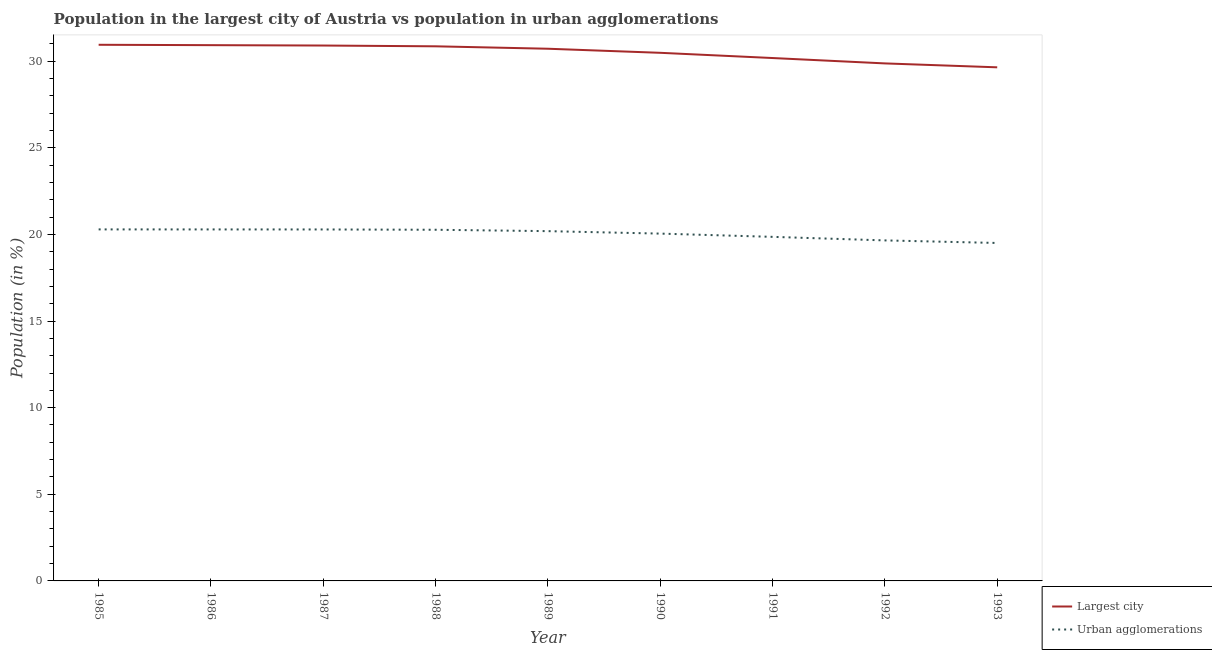How many different coloured lines are there?
Provide a succinct answer. 2. Does the line corresponding to population in the largest city intersect with the line corresponding to population in urban agglomerations?
Keep it short and to the point. No. Is the number of lines equal to the number of legend labels?
Offer a terse response. Yes. What is the population in urban agglomerations in 1989?
Keep it short and to the point. 20.19. Across all years, what is the maximum population in the largest city?
Your response must be concise. 30.94. Across all years, what is the minimum population in urban agglomerations?
Your answer should be very brief. 19.51. In which year was the population in the largest city maximum?
Ensure brevity in your answer.  1985. What is the total population in the largest city in the graph?
Offer a terse response. 274.51. What is the difference between the population in urban agglomerations in 1987 and that in 1993?
Give a very brief answer. 0.78. What is the difference between the population in the largest city in 1990 and the population in urban agglomerations in 1986?
Offer a very short reply. 10.19. What is the average population in urban agglomerations per year?
Your answer should be very brief. 20.04. In the year 1989, what is the difference between the population in the largest city and population in urban agglomerations?
Provide a short and direct response. 10.53. What is the ratio of the population in the largest city in 1988 to that in 1993?
Provide a succinct answer. 1.04. What is the difference between the highest and the second highest population in the largest city?
Offer a terse response. 0.02. What is the difference between the highest and the lowest population in urban agglomerations?
Offer a terse response. 0.78. Is the sum of the population in urban agglomerations in 1992 and 1993 greater than the maximum population in the largest city across all years?
Ensure brevity in your answer.  Yes. Is the population in urban agglomerations strictly greater than the population in the largest city over the years?
Your answer should be compact. No. How many lines are there?
Provide a succinct answer. 2. Are the values on the major ticks of Y-axis written in scientific E-notation?
Ensure brevity in your answer.  No. Does the graph contain grids?
Offer a very short reply. No. How are the legend labels stacked?
Keep it short and to the point. Vertical. What is the title of the graph?
Offer a very short reply. Population in the largest city of Austria vs population in urban agglomerations. Does "Primary income" appear as one of the legend labels in the graph?
Provide a succinct answer. No. What is the Population (in %) in Largest city in 1985?
Ensure brevity in your answer.  30.94. What is the Population (in %) of Urban agglomerations in 1985?
Provide a succinct answer. 20.29. What is the Population (in %) of Largest city in 1986?
Keep it short and to the point. 30.92. What is the Population (in %) in Urban agglomerations in 1986?
Offer a very short reply. 20.29. What is the Population (in %) of Largest city in 1987?
Your response must be concise. 30.9. What is the Population (in %) of Urban agglomerations in 1987?
Make the answer very short. 20.29. What is the Population (in %) of Largest city in 1988?
Your answer should be very brief. 30.86. What is the Population (in %) in Urban agglomerations in 1988?
Make the answer very short. 20.27. What is the Population (in %) of Largest city in 1989?
Provide a short and direct response. 30.72. What is the Population (in %) of Urban agglomerations in 1989?
Your response must be concise. 20.19. What is the Population (in %) in Largest city in 1990?
Provide a succinct answer. 30.48. What is the Population (in %) in Urban agglomerations in 1990?
Offer a very short reply. 20.05. What is the Population (in %) in Largest city in 1991?
Make the answer very short. 30.18. What is the Population (in %) of Urban agglomerations in 1991?
Offer a very short reply. 19.86. What is the Population (in %) of Largest city in 1992?
Provide a succinct answer. 29.87. What is the Population (in %) of Urban agglomerations in 1992?
Your answer should be compact. 19.65. What is the Population (in %) of Largest city in 1993?
Your answer should be compact. 29.64. What is the Population (in %) in Urban agglomerations in 1993?
Provide a succinct answer. 19.51. Across all years, what is the maximum Population (in %) in Largest city?
Make the answer very short. 30.94. Across all years, what is the maximum Population (in %) in Urban agglomerations?
Your response must be concise. 20.29. Across all years, what is the minimum Population (in %) of Largest city?
Your answer should be very brief. 29.64. Across all years, what is the minimum Population (in %) of Urban agglomerations?
Keep it short and to the point. 19.51. What is the total Population (in %) of Largest city in the graph?
Offer a very short reply. 274.51. What is the total Population (in %) in Urban agglomerations in the graph?
Give a very brief answer. 180.38. What is the difference between the Population (in %) of Largest city in 1985 and that in 1986?
Your answer should be compact. 0.02. What is the difference between the Population (in %) of Urban agglomerations in 1985 and that in 1986?
Ensure brevity in your answer.  0. What is the difference between the Population (in %) of Largest city in 1985 and that in 1987?
Ensure brevity in your answer.  0.04. What is the difference between the Population (in %) of Urban agglomerations in 1985 and that in 1987?
Keep it short and to the point. 0. What is the difference between the Population (in %) in Largest city in 1985 and that in 1988?
Make the answer very short. 0.09. What is the difference between the Population (in %) in Urban agglomerations in 1985 and that in 1988?
Offer a very short reply. 0.02. What is the difference between the Population (in %) of Largest city in 1985 and that in 1989?
Ensure brevity in your answer.  0.23. What is the difference between the Population (in %) of Urban agglomerations in 1985 and that in 1989?
Provide a succinct answer. 0.1. What is the difference between the Population (in %) of Largest city in 1985 and that in 1990?
Provide a short and direct response. 0.46. What is the difference between the Population (in %) of Urban agglomerations in 1985 and that in 1990?
Provide a succinct answer. 0.24. What is the difference between the Population (in %) in Largest city in 1985 and that in 1991?
Provide a succinct answer. 0.76. What is the difference between the Population (in %) in Urban agglomerations in 1985 and that in 1991?
Your response must be concise. 0.43. What is the difference between the Population (in %) in Largest city in 1985 and that in 1992?
Your answer should be very brief. 1.08. What is the difference between the Population (in %) of Urban agglomerations in 1985 and that in 1992?
Provide a short and direct response. 0.64. What is the difference between the Population (in %) in Largest city in 1985 and that in 1993?
Keep it short and to the point. 1.3. What is the difference between the Population (in %) of Urban agglomerations in 1985 and that in 1993?
Provide a short and direct response. 0.78. What is the difference between the Population (in %) of Largest city in 1986 and that in 1987?
Offer a terse response. 0.02. What is the difference between the Population (in %) in Urban agglomerations in 1986 and that in 1987?
Your response must be concise. 0. What is the difference between the Population (in %) of Largest city in 1986 and that in 1988?
Ensure brevity in your answer.  0.07. What is the difference between the Population (in %) of Urban agglomerations in 1986 and that in 1988?
Your answer should be very brief. 0.02. What is the difference between the Population (in %) of Largest city in 1986 and that in 1989?
Your response must be concise. 0.21. What is the difference between the Population (in %) of Urban agglomerations in 1986 and that in 1989?
Your response must be concise. 0.1. What is the difference between the Population (in %) of Largest city in 1986 and that in 1990?
Provide a succinct answer. 0.44. What is the difference between the Population (in %) in Urban agglomerations in 1986 and that in 1990?
Your answer should be very brief. 0.24. What is the difference between the Population (in %) in Largest city in 1986 and that in 1991?
Ensure brevity in your answer.  0.74. What is the difference between the Population (in %) in Urban agglomerations in 1986 and that in 1991?
Provide a succinct answer. 0.43. What is the difference between the Population (in %) in Largest city in 1986 and that in 1992?
Keep it short and to the point. 1.05. What is the difference between the Population (in %) in Urban agglomerations in 1986 and that in 1992?
Keep it short and to the point. 0.63. What is the difference between the Population (in %) in Largest city in 1986 and that in 1993?
Offer a very short reply. 1.28. What is the difference between the Population (in %) in Urban agglomerations in 1986 and that in 1993?
Your answer should be very brief. 0.78. What is the difference between the Population (in %) of Largest city in 1987 and that in 1988?
Your answer should be very brief. 0.05. What is the difference between the Population (in %) in Urban agglomerations in 1987 and that in 1988?
Ensure brevity in your answer.  0.02. What is the difference between the Population (in %) in Largest city in 1987 and that in 1989?
Give a very brief answer. 0.19. What is the difference between the Population (in %) of Urban agglomerations in 1987 and that in 1989?
Offer a terse response. 0.1. What is the difference between the Population (in %) in Largest city in 1987 and that in 1990?
Your answer should be very brief. 0.42. What is the difference between the Population (in %) in Urban agglomerations in 1987 and that in 1990?
Ensure brevity in your answer.  0.24. What is the difference between the Population (in %) of Largest city in 1987 and that in 1991?
Keep it short and to the point. 0.72. What is the difference between the Population (in %) of Urban agglomerations in 1987 and that in 1991?
Ensure brevity in your answer.  0.43. What is the difference between the Population (in %) in Largest city in 1987 and that in 1992?
Ensure brevity in your answer.  1.03. What is the difference between the Population (in %) in Urban agglomerations in 1987 and that in 1992?
Ensure brevity in your answer.  0.63. What is the difference between the Population (in %) of Largest city in 1987 and that in 1993?
Make the answer very short. 1.26. What is the difference between the Population (in %) in Urban agglomerations in 1987 and that in 1993?
Provide a succinct answer. 0.78. What is the difference between the Population (in %) of Largest city in 1988 and that in 1989?
Make the answer very short. 0.14. What is the difference between the Population (in %) in Largest city in 1988 and that in 1990?
Your response must be concise. 0.37. What is the difference between the Population (in %) in Urban agglomerations in 1988 and that in 1990?
Offer a terse response. 0.22. What is the difference between the Population (in %) of Largest city in 1988 and that in 1991?
Ensure brevity in your answer.  0.68. What is the difference between the Population (in %) of Urban agglomerations in 1988 and that in 1991?
Offer a very short reply. 0.41. What is the difference between the Population (in %) in Largest city in 1988 and that in 1992?
Make the answer very short. 0.99. What is the difference between the Population (in %) in Urban agglomerations in 1988 and that in 1992?
Provide a succinct answer. 0.61. What is the difference between the Population (in %) of Largest city in 1988 and that in 1993?
Your answer should be compact. 1.21. What is the difference between the Population (in %) of Urban agglomerations in 1988 and that in 1993?
Keep it short and to the point. 0.76. What is the difference between the Population (in %) of Largest city in 1989 and that in 1990?
Your response must be concise. 0.23. What is the difference between the Population (in %) in Urban agglomerations in 1989 and that in 1990?
Provide a succinct answer. 0.14. What is the difference between the Population (in %) of Largest city in 1989 and that in 1991?
Make the answer very short. 0.54. What is the difference between the Population (in %) of Urban agglomerations in 1989 and that in 1991?
Provide a short and direct response. 0.33. What is the difference between the Population (in %) of Largest city in 1989 and that in 1992?
Provide a succinct answer. 0.85. What is the difference between the Population (in %) of Urban agglomerations in 1989 and that in 1992?
Keep it short and to the point. 0.53. What is the difference between the Population (in %) of Largest city in 1989 and that in 1993?
Offer a very short reply. 1.07. What is the difference between the Population (in %) of Urban agglomerations in 1989 and that in 1993?
Make the answer very short. 0.68. What is the difference between the Population (in %) of Largest city in 1990 and that in 1991?
Your answer should be compact. 0.3. What is the difference between the Population (in %) of Urban agglomerations in 1990 and that in 1991?
Offer a very short reply. 0.19. What is the difference between the Population (in %) in Largest city in 1990 and that in 1992?
Make the answer very short. 0.61. What is the difference between the Population (in %) in Urban agglomerations in 1990 and that in 1992?
Provide a short and direct response. 0.39. What is the difference between the Population (in %) in Largest city in 1990 and that in 1993?
Provide a short and direct response. 0.84. What is the difference between the Population (in %) of Urban agglomerations in 1990 and that in 1993?
Keep it short and to the point. 0.54. What is the difference between the Population (in %) of Largest city in 1991 and that in 1992?
Ensure brevity in your answer.  0.31. What is the difference between the Population (in %) of Urban agglomerations in 1991 and that in 1992?
Keep it short and to the point. 0.2. What is the difference between the Population (in %) in Largest city in 1991 and that in 1993?
Offer a terse response. 0.54. What is the difference between the Population (in %) of Urban agglomerations in 1991 and that in 1993?
Provide a succinct answer. 0.35. What is the difference between the Population (in %) in Largest city in 1992 and that in 1993?
Provide a short and direct response. 0.23. What is the difference between the Population (in %) in Urban agglomerations in 1992 and that in 1993?
Provide a succinct answer. 0.15. What is the difference between the Population (in %) of Largest city in 1985 and the Population (in %) of Urban agglomerations in 1986?
Your response must be concise. 10.66. What is the difference between the Population (in %) in Largest city in 1985 and the Population (in %) in Urban agglomerations in 1987?
Ensure brevity in your answer.  10.66. What is the difference between the Population (in %) in Largest city in 1985 and the Population (in %) in Urban agglomerations in 1988?
Offer a terse response. 10.68. What is the difference between the Population (in %) of Largest city in 1985 and the Population (in %) of Urban agglomerations in 1989?
Provide a short and direct response. 10.76. What is the difference between the Population (in %) of Largest city in 1985 and the Population (in %) of Urban agglomerations in 1990?
Provide a succinct answer. 10.9. What is the difference between the Population (in %) in Largest city in 1985 and the Population (in %) in Urban agglomerations in 1991?
Your answer should be very brief. 11.09. What is the difference between the Population (in %) in Largest city in 1985 and the Population (in %) in Urban agglomerations in 1992?
Your answer should be compact. 11.29. What is the difference between the Population (in %) in Largest city in 1985 and the Population (in %) in Urban agglomerations in 1993?
Your answer should be compact. 11.44. What is the difference between the Population (in %) in Largest city in 1986 and the Population (in %) in Urban agglomerations in 1987?
Ensure brevity in your answer.  10.64. What is the difference between the Population (in %) in Largest city in 1986 and the Population (in %) in Urban agglomerations in 1988?
Offer a very short reply. 10.65. What is the difference between the Population (in %) of Largest city in 1986 and the Population (in %) of Urban agglomerations in 1989?
Your response must be concise. 10.73. What is the difference between the Population (in %) of Largest city in 1986 and the Population (in %) of Urban agglomerations in 1990?
Offer a very short reply. 10.88. What is the difference between the Population (in %) in Largest city in 1986 and the Population (in %) in Urban agglomerations in 1991?
Offer a terse response. 11.06. What is the difference between the Population (in %) in Largest city in 1986 and the Population (in %) in Urban agglomerations in 1992?
Your response must be concise. 11.27. What is the difference between the Population (in %) in Largest city in 1986 and the Population (in %) in Urban agglomerations in 1993?
Give a very brief answer. 11.42. What is the difference between the Population (in %) in Largest city in 1987 and the Population (in %) in Urban agglomerations in 1988?
Your response must be concise. 10.63. What is the difference between the Population (in %) in Largest city in 1987 and the Population (in %) in Urban agglomerations in 1989?
Your answer should be compact. 10.71. What is the difference between the Population (in %) of Largest city in 1987 and the Population (in %) of Urban agglomerations in 1990?
Provide a succinct answer. 10.86. What is the difference between the Population (in %) of Largest city in 1987 and the Population (in %) of Urban agglomerations in 1991?
Your answer should be compact. 11.04. What is the difference between the Population (in %) of Largest city in 1987 and the Population (in %) of Urban agglomerations in 1992?
Provide a short and direct response. 11.25. What is the difference between the Population (in %) of Largest city in 1987 and the Population (in %) of Urban agglomerations in 1993?
Offer a very short reply. 11.4. What is the difference between the Population (in %) of Largest city in 1988 and the Population (in %) of Urban agglomerations in 1989?
Make the answer very short. 10.67. What is the difference between the Population (in %) of Largest city in 1988 and the Population (in %) of Urban agglomerations in 1990?
Your answer should be very brief. 10.81. What is the difference between the Population (in %) in Largest city in 1988 and the Population (in %) in Urban agglomerations in 1991?
Your answer should be very brief. 11. What is the difference between the Population (in %) in Largest city in 1988 and the Population (in %) in Urban agglomerations in 1992?
Provide a succinct answer. 11.2. What is the difference between the Population (in %) in Largest city in 1988 and the Population (in %) in Urban agglomerations in 1993?
Provide a short and direct response. 11.35. What is the difference between the Population (in %) of Largest city in 1989 and the Population (in %) of Urban agglomerations in 1990?
Give a very brief answer. 10.67. What is the difference between the Population (in %) in Largest city in 1989 and the Population (in %) in Urban agglomerations in 1991?
Offer a very short reply. 10.86. What is the difference between the Population (in %) of Largest city in 1989 and the Population (in %) of Urban agglomerations in 1992?
Your answer should be compact. 11.06. What is the difference between the Population (in %) in Largest city in 1989 and the Population (in %) in Urban agglomerations in 1993?
Your response must be concise. 11.21. What is the difference between the Population (in %) in Largest city in 1990 and the Population (in %) in Urban agglomerations in 1991?
Ensure brevity in your answer.  10.62. What is the difference between the Population (in %) of Largest city in 1990 and the Population (in %) of Urban agglomerations in 1992?
Provide a succinct answer. 10.83. What is the difference between the Population (in %) of Largest city in 1990 and the Population (in %) of Urban agglomerations in 1993?
Your response must be concise. 10.98. What is the difference between the Population (in %) in Largest city in 1991 and the Population (in %) in Urban agglomerations in 1992?
Your answer should be very brief. 10.53. What is the difference between the Population (in %) of Largest city in 1991 and the Population (in %) of Urban agglomerations in 1993?
Give a very brief answer. 10.67. What is the difference between the Population (in %) in Largest city in 1992 and the Population (in %) in Urban agglomerations in 1993?
Give a very brief answer. 10.36. What is the average Population (in %) of Largest city per year?
Give a very brief answer. 30.5. What is the average Population (in %) of Urban agglomerations per year?
Ensure brevity in your answer.  20.04. In the year 1985, what is the difference between the Population (in %) of Largest city and Population (in %) of Urban agglomerations?
Keep it short and to the point. 10.66. In the year 1986, what is the difference between the Population (in %) of Largest city and Population (in %) of Urban agglomerations?
Your response must be concise. 10.64. In the year 1987, what is the difference between the Population (in %) of Largest city and Population (in %) of Urban agglomerations?
Ensure brevity in your answer.  10.62. In the year 1988, what is the difference between the Population (in %) of Largest city and Population (in %) of Urban agglomerations?
Offer a terse response. 10.59. In the year 1989, what is the difference between the Population (in %) in Largest city and Population (in %) in Urban agglomerations?
Keep it short and to the point. 10.53. In the year 1990, what is the difference between the Population (in %) of Largest city and Population (in %) of Urban agglomerations?
Give a very brief answer. 10.44. In the year 1991, what is the difference between the Population (in %) of Largest city and Population (in %) of Urban agglomerations?
Keep it short and to the point. 10.32. In the year 1992, what is the difference between the Population (in %) in Largest city and Population (in %) in Urban agglomerations?
Keep it short and to the point. 10.22. In the year 1993, what is the difference between the Population (in %) in Largest city and Population (in %) in Urban agglomerations?
Keep it short and to the point. 10.14. What is the ratio of the Population (in %) of Largest city in 1985 to that in 1988?
Offer a terse response. 1. What is the ratio of the Population (in %) in Urban agglomerations in 1985 to that in 1988?
Make the answer very short. 1. What is the ratio of the Population (in %) of Largest city in 1985 to that in 1989?
Offer a terse response. 1.01. What is the ratio of the Population (in %) in Largest city in 1985 to that in 1990?
Ensure brevity in your answer.  1.02. What is the ratio of the Population (in %) of Urban agglomerations in 1985 to that in 1990?
Provide a succinct answer. 1.01. What is the ratio of the Population (in %) in Largest city in 1985 to that in 1991?
Your response must be concise. 1.03. What is the ratio of the Population (in %) of Urban agglomerations in 1985 to that in 1991?
Your answer should be very brief. 1.02. What is the ratio of the Population (in %) of Largest city in 1985 to that in 1992?
Ensure brevity in your answer.  1.04. What is the ratio of the Population (in %) of Urban agglomerations in 1985 to that in 1992?
Offer a very short reply. 1.03. What is the ratio of the Population (in %) in Largest city in 1985 to that in 1993?
Offer a terse response. 1.04. What is the ratio of the Population (in %) in Urban agglomerations in 1985 to that in 1993?
Your answer should be very brief. 1.04. What is the ratio of the Population (in %) of Largest city in 1986 to that in 1987?
Offer a terse response. 1. What is the ratio of the Population (in %) in Urban agglomerations in 1986 to that in 1987?
Provide a succinct answer. 1. What is the ratio of the Population (in %) in Largest city in 1986 to that in 1988?
Your answer should be compact. 1. What is the ratio of the Population (in %) in Largest city in 1986 to that in 1989?
Offer a terse response. 1.01. What is the ratio of the Population (in %) of Largest city in 1986 to that in 1990?
Provide a succinct answer. 1.01. What is the ratio of the Population (in %) of Largest city in 1986 to that in 1991?
Make the answer very short. 1.02. What is the ratio of the Population (in %) in Urban agglomerations in 1986 to that in 1991?
Ensure brevity in your answer.  1.02. What is the ratio of the Population (in %) in Largest city in 1986 to that in 1992?
Ensure brevity in your answer.  1.04. What is the ratio of the Population (in %) in Urban agglomerations in 1986 to that in 1992?
Your response must be concise. 1.03. What is the ratio of the Population (in %) in Largest city in 1986 to that in 1993?
Make the answer very short. 1.04. What is the ratio of the Population (in %) in Urban agglomerations in 1986 to that in 1993?
Make the answer very short. 1.04. What is the ratio of the Population (in %) in Urban agglomerations in 1987 to that in 1988?
Keep it short and to the point. 1. What is the ratio of the Population (in %) of Largest city in 1987 to that in 1989?
Ensure brevity in your answer.  1.01. What is the ratio of the Population (in %) in Urban agglomerations in 1987 to that in 1989?
Provide a short and direct response. 1. What is the ratio of the Population (in %) in Largest city in 1987 to that in 1990?
Your answer should be very brief. 1.01. What is the ratio of the Population (in %) of Urban agglomerations in 1987 to that in 1990?
Provide a short and direct response. 1.01. What is the ratio of the Population (in %) in Largest city in 1987 to that in 1991?
Your answer should be very brief. 1.02. What is the ratio of the Population (in %) of Urban agglomerations in 1987 to that in 1991?
Make the answer very short. 1.02. What is the ratio of the Population (in %) in Largest city in 1987 to that in 1992?
Your response must be concise. 1.03. What is the ratio of the Population (in %) of Urban agglomerations in 1987 to that in 1992?
Your answer should be very brief. 1.03. What is the ratio of the Population (in %) in Largest city in 1987 to that in 1993?
Keep it short and to the point. 1.04. What is the ratio of the Population (in %) in Urban agglomerations in 1988 to that in 1989?
Provide a succinct answer. 1. What is the ratio of the Population (in %) in Largest city in 1988 to that in 1990?
Provide a succinct answer. 1.01. What is the ratio of the Population (in %) in Urban agglomerations in 1988 to that in 1990?
Give a very brief answer. 1.01. What is the ratio of the Population (in %) in Largest city in 1988 to that in 1991?
Keep it short and to the point. 1.02. What is the ratio of the Population (in %) of Urban agglomerations in 1988 to that in 1991?
Your response must be concise. 1.02. What is the ratio of the Population (in %) in Largest city in 1988 to that in 1992?
Offer a very short reply. 1.03. What is the ratio of the Population (in %) of Urban agglomerations in 1988 to that in 1992?
Make the answer very short. 1.03. What is the ratio of the Population (in %) of Largest city in 1988 to that in 1993?
Your response must be concise. 1.04. What is the ratio of the Population (in %) of Urban agglomerations in 1988 to that in 1993?
Make the answer very short. 1.04. What is the ratio of the Population (in %) of Largest city in 1989 to that in 1990?
Your response must be concise. 1.01. What is the ratio of the Population (in %) in Urban agglomerations in 1989 to that in 1990?
Ensure brevity in your answer.  1.01. What is the ratio of the Population (in %) in Largest city in 1989 to that in 1991?
Ensure brevity in your answer.  1.02. What is the ratio of the Population (in %) in Urban agglomerations in 1989 to that in 1991?
Offer a terse response. 1.02. What is the ratio of the Population (in %) in Largest city in 1989 to that in 1992?
Provide a succinct answer. 1.03. What is the ratio of the Population (in %) of Urban agglomerations in 1989 to that in 1992?
Make the answer very short. 1.03. What is the ratio of the Population (in %) in Largest city in 1989 to that in 1993?
Provide a succinct answer. 1.04. What is the ratio of the Population (in %) of Urban agglomerations in 1989 to that in 1993?
Keep it short and to the point. 1.03. What is the ratio of the Population (in %) in Urban agglomerations in 1990 to that in 1991?
Keep it short and to the point. 1.01. What is the ratio of the Population (in %) of Largest city in 1990 to that in 1992?
Provide a succinct answer. 1.02. What is the ratio of the Population (in %) of Largest city in 1990 to that in 1993?
Your response must be concise. 1.03. What is the ratio of the Population (in %) in Urban agglomerations in 1990 to that in 1993?
Provide a succinct answer. 1.03. What is the ratio of the Population (in %) in Largest city in 1991 to that in 1992?
Make the answer very short. 1.01. What is the ratio of the Population (in %) of Urban agglomerations in 1991 to that in 1992?
Ensure brevity in your answer.  1.01. What is the ratio of the Population (in %) of Largest city in 1991 to that in 1993?
Your response must be concise. 1.02. What is the ratio of the Population (in %) of Urban agglomerations in 1991 to that in 1993?
Ensure brevity in your answer.  1.02. What is the ratio of the Population (in %) in Largest city in 1992 to that in 1993?
Give a very brief answer. 1.01. What is the ratio of the Population (in %) in Urban agglomerations in 1992 to that in 1993?
Your answer should be very brief. 1.01. What is the difference between the highest and the second highest Population (in %) of Largest city?
Offer a terse response. 0.02. What is the difference between the highest and the second highest Population (in %) in Urban agglomerations?
Ensure brevity in your answer.  0. What is the difference between the highest and the lowest Population (in %) in Largest city?
Offer a terse response. 1.3. What is the difference between the highest and the lowest Population (in %) of Urban agglomerations?
Give a very brief answer. 0.78. 